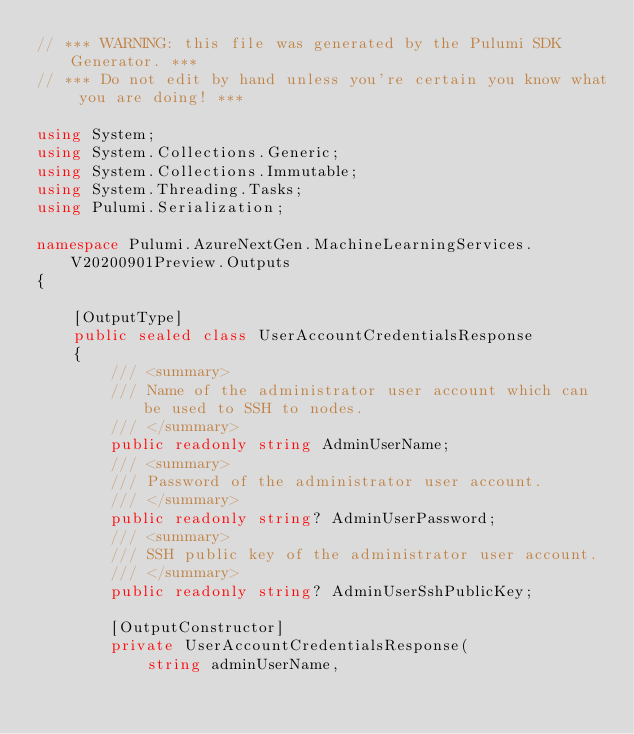<code> <loc_0><loc_0><loc_500><loc_500><_C#_>// *** WARNING: this file was generated by the Pulumi SDK Generator. ***
// *** Do not edit by hand unless you're certain you know what you are doing! ***

using System;
using System.Collections.Generic;
using System.Collections.Immutable;
using System.Threading.Tasks;
using Pulumi.Serialization;

namespace Pulumi.AzureNextGen.MachineLearningServices.V20200901Preview.Outputs
{

    [OutputType]
    public sealed class UserAccountCredentialsResponse
    {
        /// <summary>
        /// Name of the administrator user account which can be used to SSH to nodes.
        /// </summary>
        public readonly string AdminUserName;
        /// <summary>
        /// Password of the administrator user account.
        /// </summary>
        public readonly string? AdminUserPassword;
        /// <summary>
        /// SSH public key of the administrator user account.
        /// </summary>
        public readonly string? AdminUserSshPublicKey;

        [OutputConstructor]
        private UserAccountCredentialsResponse(
            string adminUserName,
</code> 